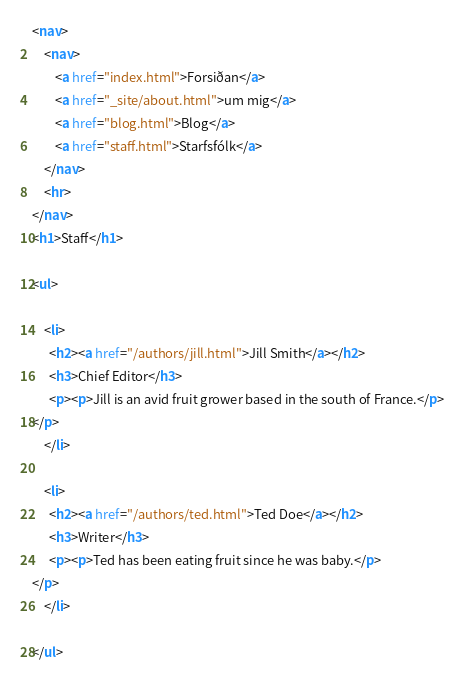<code> <loc_0><loc_0><loc_500><loc_500><_HTML_><nav>
    <nav>
        <a href="index.html">Forsiðan</a>
        <a href="_site/about.html">um mig</a>
        <a href="blog.html">Blog</a>
        <a href="staff.html">Starfsfólk</a>
    </nav>
    <hr>
</nav>
<h1>Staff</h1>

<ul>
  
    <li>
      <h2><a href="/authors/jill.html">Jill Smith</a></h2>
      <h3>Chief Editor</h3>
      <p><p>Jill is an avid fruit grower based in the south of France.</p>
</p>
    </li>
  
    <li>
      <h2><a href="/authors/ted.html">Ted Doe</a></h2>
      <h3>Writer</h3>
      <p><p>Ted has been eating fruit since he was baby.</p>
</p>
    </li>
  
</ul></code> 